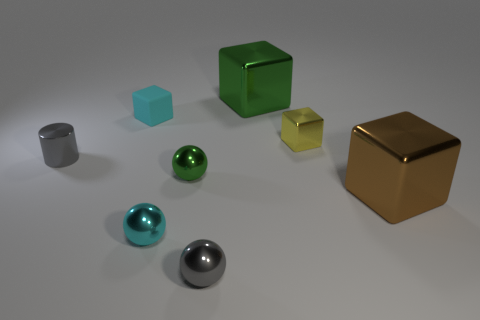Add 1 cubes. How many objects exist? 9 Subtract all green metal cubes. How many cubes are left? 3 Subtract all brown cubes. How many cubes are left? 3 Add 5 yellow cubes. How many yellow cubes are left? 6 Add 6 purple matte spheres. How many purple matte spheres exist? 6 Subtract 1 brown cubes. How many objects are left? 7 Subtract all spheres. How many objects are left? 5 Subtract 1 cylinders. How many cylinders are left? 0 Subtract all yellow spheres. Subtract all red blocks. How many spheres are left? 3 Subtract all tiny gray matte cylinders. Subtract all small rubber objects. How many objects are left? 7 